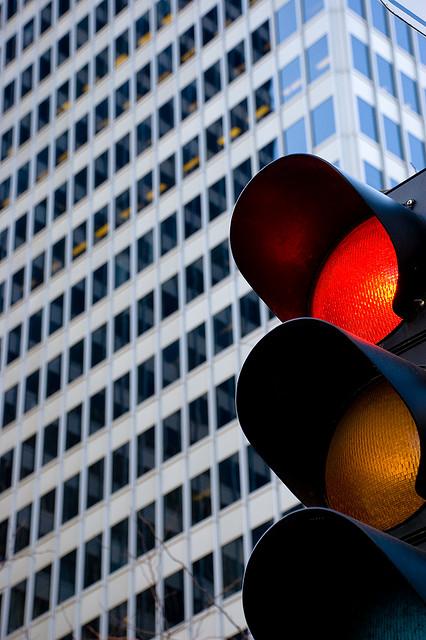Is there a skyscraper in the background?
Concise answer only. Yes. Is the traffic signal red?
Keep it brief. Yes. Does the building have an elevator?
Concise answer only. Yes. What color is the traffic light?
Write a very short answer. Red. What color is the light that is lit?
Give a very brief answer. Red. Is the bottom light lit up?
Concise answer only. No. 